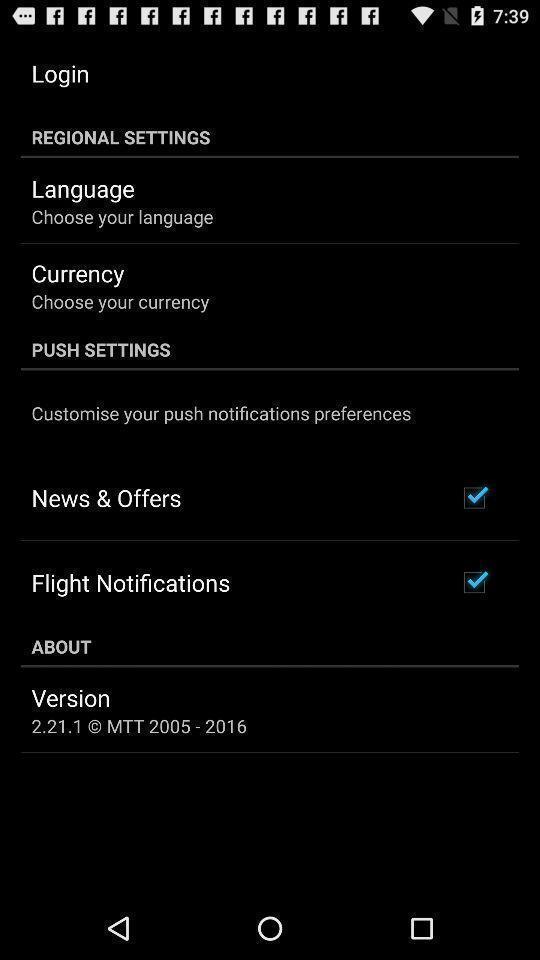Summarize the information in this screenshot. Page displaying settings information about an application. 